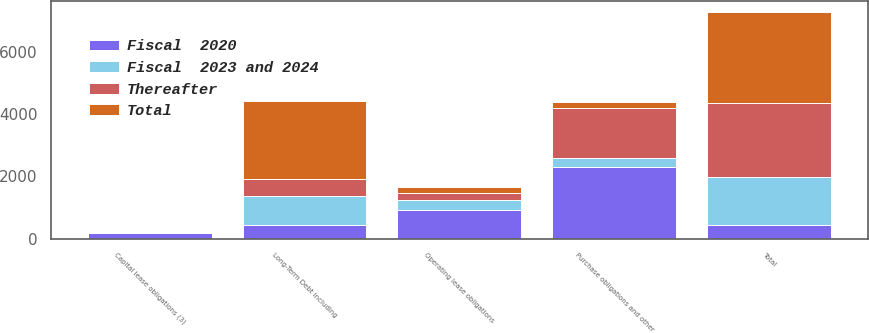Convert chart. <chart><loc_0><loc_0><loc_500><loc_500><stacked_bar_chart><ecel><fcel>Long-Term Debt including<fcel>Operating lease obligations<fcel>Capital lease obligations (3)<fcel>Purchase obligations and other<fcel>Total<nl><fcel>Fiscal  2020<fcel>433.6<fcel>930.4<fcel>168.9<fcel>2293.5<fcel>433.6<nl><fcel>Thereafter<fcel>550.8<fcel>214.3<fcel>6.4<fcel>1607<fcel>2378.5<nl><fcel>Fiscal  2023 and 2024<fcel>939.8<fcel>316.4<fcel>8.7<fcel>292.5<fcel>1557.4<nl><fcel>Total<fcel>2494.3<fcel>193.6<fcel>2.9<fcel>206.7<fcel>2897.5<nl></chart> 